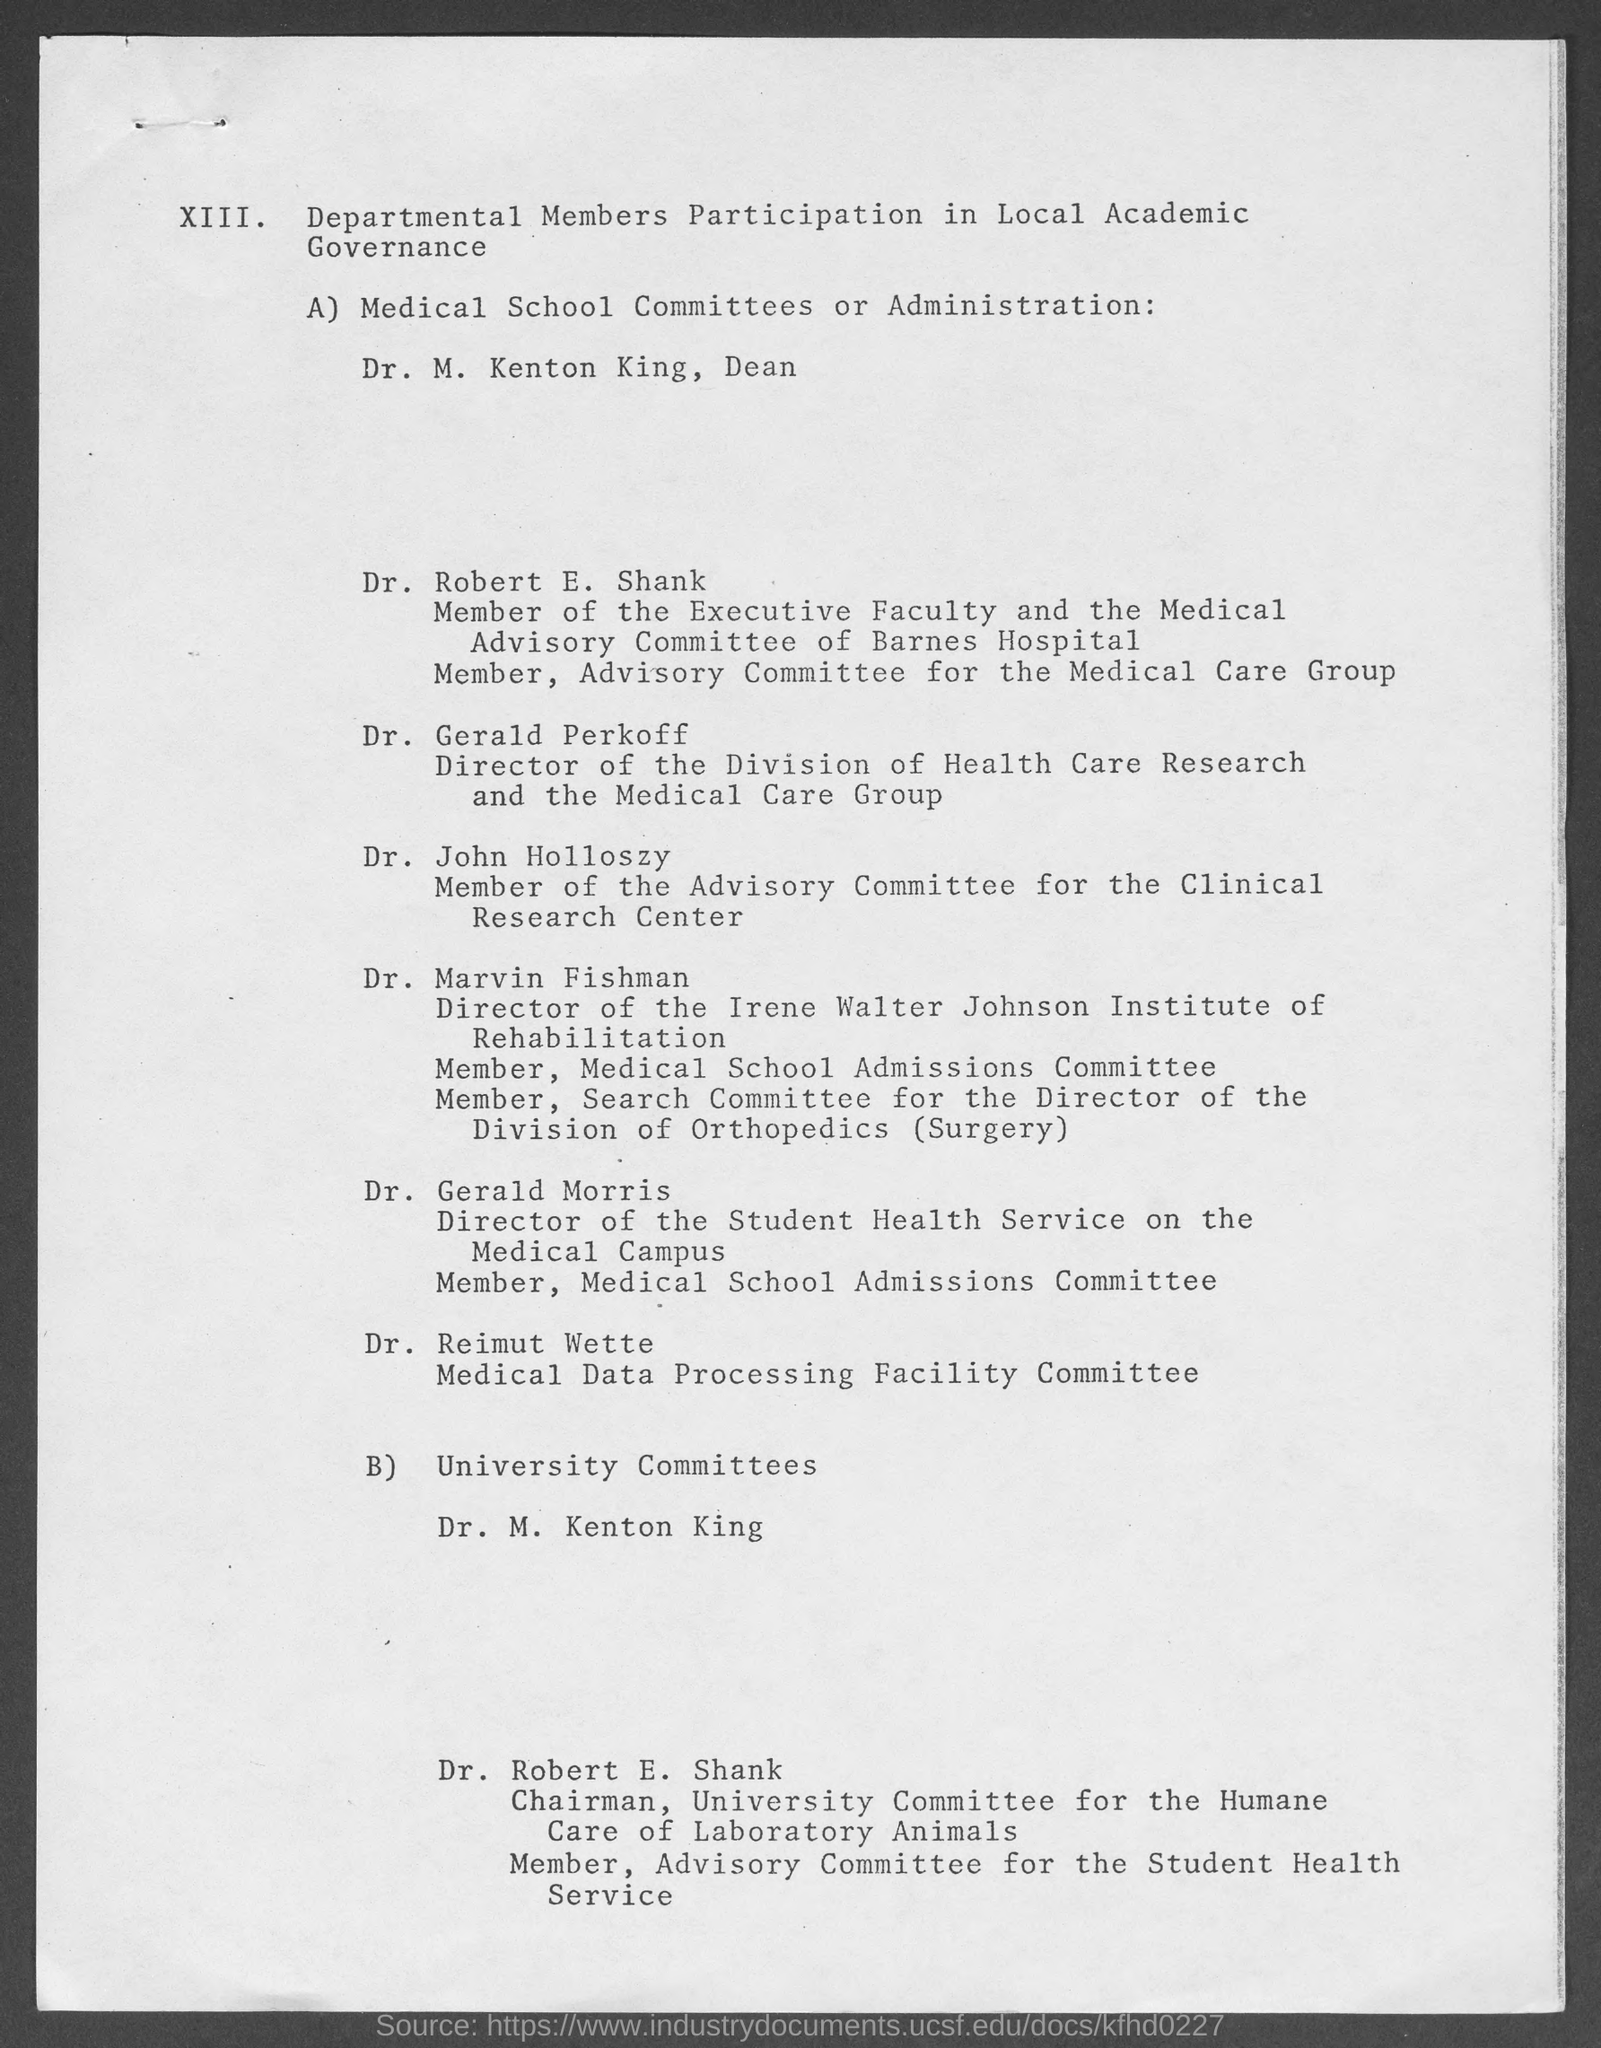Draw attention to some important aspects in this diagram. The director of the Division of Health Care Research and the Medical Care Group is Dr. Gerald Perkoff. Dr. M. Kenton King holds the position of Dean. Dr. John Holloszy is a member of the advisory committee for the Clinical research center. The director of the Student Health Service on the Medical Campus is Dr. Gerald Morris. 